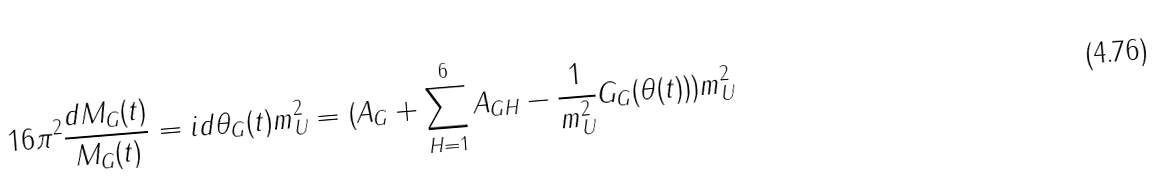<formula> <loc_0><loc_0><loc_500><loc_500>1 6 \pi ^ { 2 } \frac { d M _ { G } ( t ) } { M _ { G } ( t ) } = i d \theta _ { G } ( t ) m _ { U } ^ { 2 } = ( A _ { G } + \sum _ { H = 1 } ^ { 6 } A _ { G H } - \frac { 1 } { m _ { U } ^ { 2 } } G _ { G } ( \theta ( t ) ) ) m _ { U } ^ { 2 }</formula> 